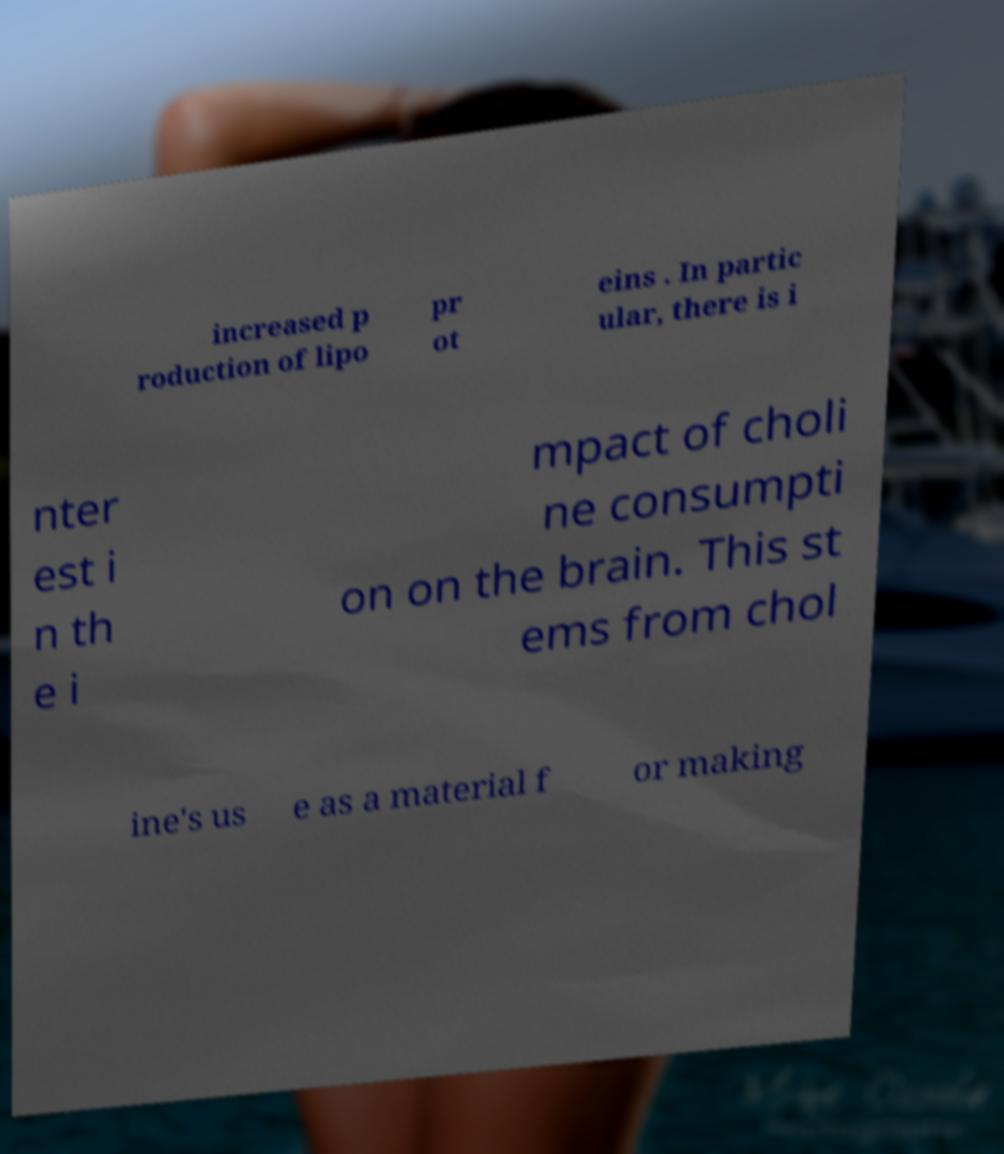Can you read and provide the text displayed in the image?This photo seems to have some interesting text. Can you extract and type it out for me? increased p roduction of lipo pr ot eins . In partic ular, there is i nter est i n th e i mpact of choli ne consumpti on on the brain. This st ems from chol ine's us e as a material f or making 